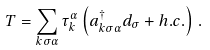Convert formula to latex. <formula><loc_0><loc_0><loc_500><loc_500>T = \sum _ { k \sigma \alpha } \tau _ { k } ^ { \alpha } \left ( a _ { k \sigma \alpha } ^ { \dagger } d _ { \sigma } + h . c . \right ) \, .</formula> 